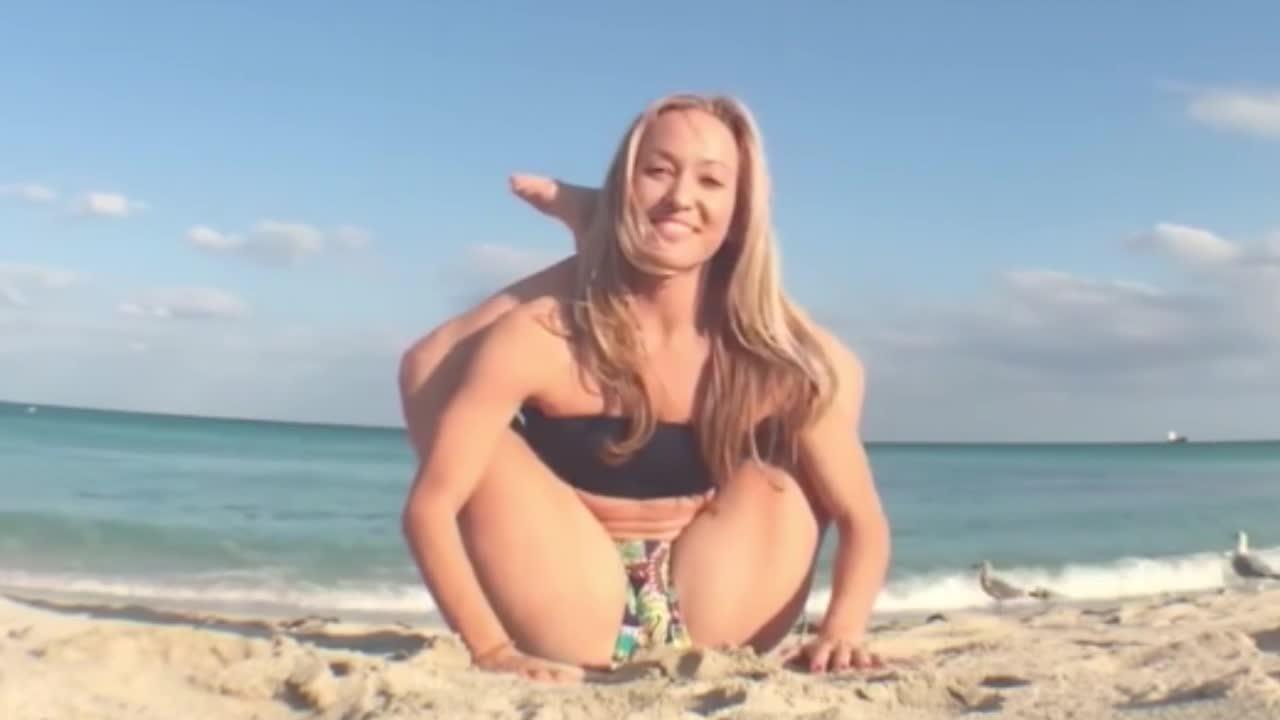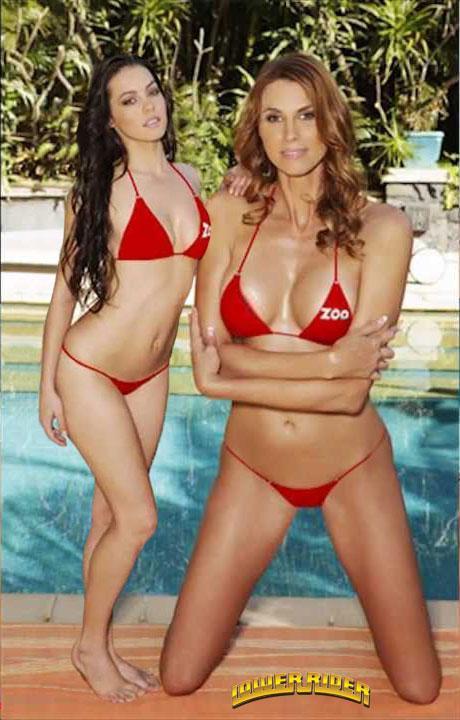The first image is the image on the left, the second image is the image on the right. Given the left and right images, does the statement "A striped bikini top is modeled in one image." hold true? Answer yes or no. No. The first image is the image on the left, the second image is the image on the right. For the images shown, is this caption "In the left image, a woman poses in a bikini on a sandy beach by herself" true? Answer yes or no. Yes. 